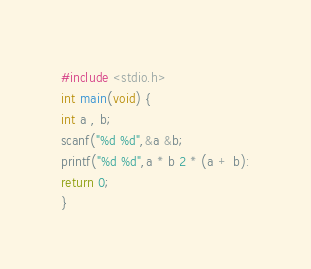Convert code to text. <code><loc_0><loc_0><loc_500><loc_500><_C_>
#include <stdio.h>
int main(void) {
int a , b;
scanf("%d %d",&a &b;
printf("%d %d",a * b 2 * (a + b):
return 0;
}</code> 